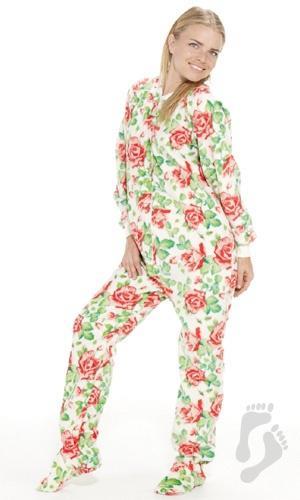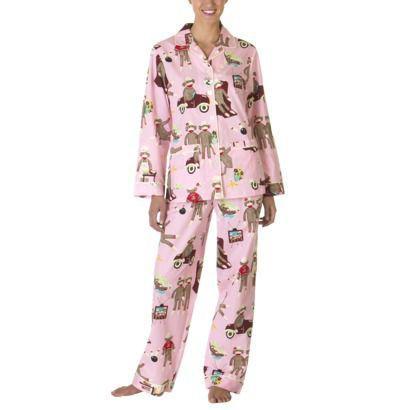The first image is the image on the left, the second image is the image on the right. Considering the images on both sides, is "Right image shows one model in pajamas with solid trim at the hems." valid? Answer yes or no. No. The first image is the image on the left, the second image is the image on the right. Examine the images to the left and right. Is the description "A pajama shirt in one image has solid contrasting trim on the shirt's bottom hem, pocket, and sleeve cuffs." accurate? Answer yes or no. No. 